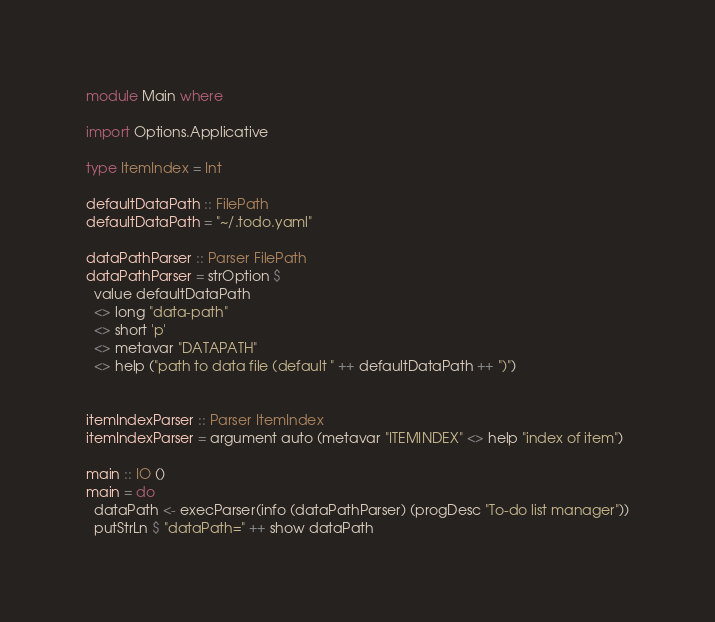<code> <loc_0><loc_0><loc_500><loc_500><_Haskell_>module Main where

import Options.Applicative

type ItemIndex = Int

defaultDataPath :: FilePath
defaultDataPath = "~/.todo.yaml"

dataPathParser :: Parser FilePath
dataPathParser = strOption $
  value defaultDataPath
  <> long "data-path"
  <> short 'p'
  <> metavar "DATAPATH"
  <> help ("path to data file (default " ++ defaultDataPath ++ ")")


itemIndexParser :: Parser ItemIndex
itemIndexParser = argument auto (metavar "ITEMINDEX" <> help "index of item")

main :: IO ()
main = do
  dataPath <- execParser(info (dataPathParser) (progDesc "To-do list manager"))
  putStrLn $ "dataPath=" ++ show dataPath</code> 